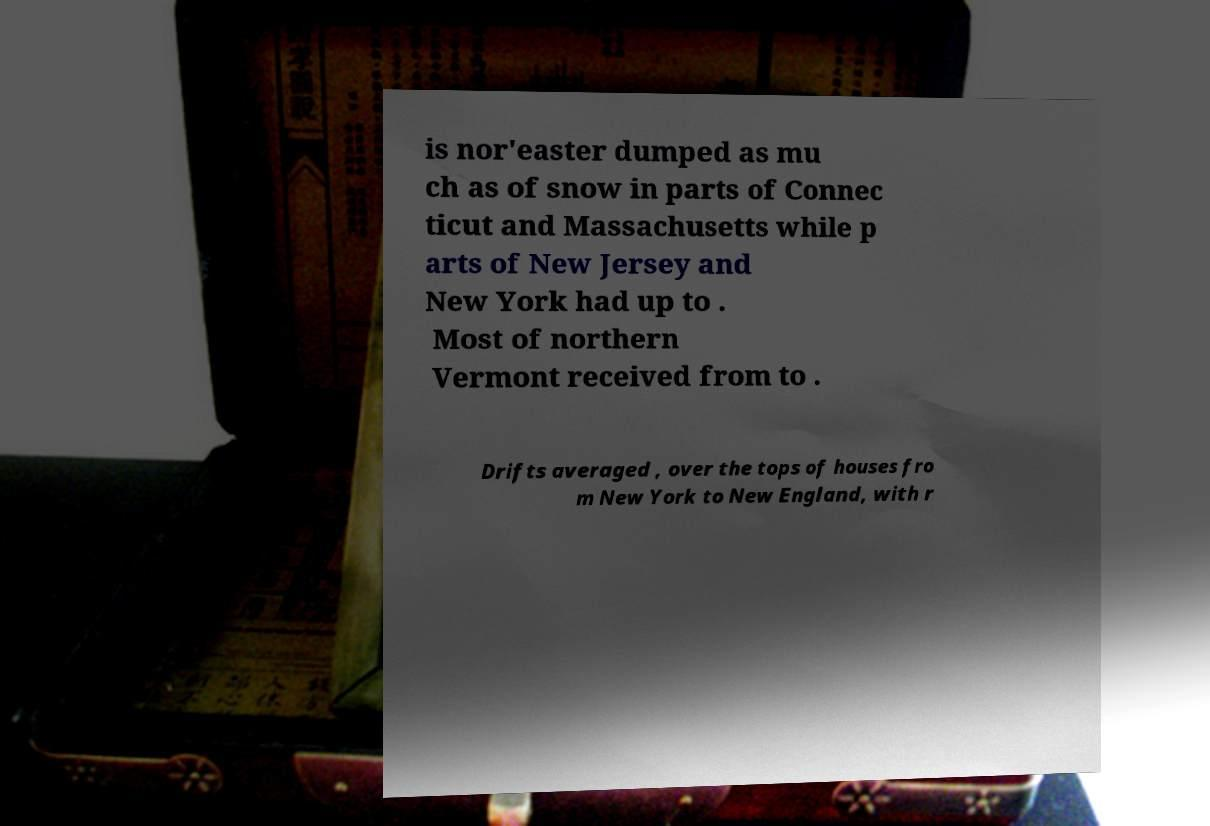Can you accurately transcribe the text from the provided image for me? is nor'easter dumped as mu ch as of snow in parts of Connec ticut and Massachusetts while p arts of New Jersey and New York had up to . Most of northern Vermont received from to . Drifts averaged , over the tops of houses fro m New York to New England, with r 